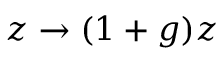<formula> <loc_0><loc_0><loc_500><loc_500>z \rightarrow ( 1 + g ) z</formula> 